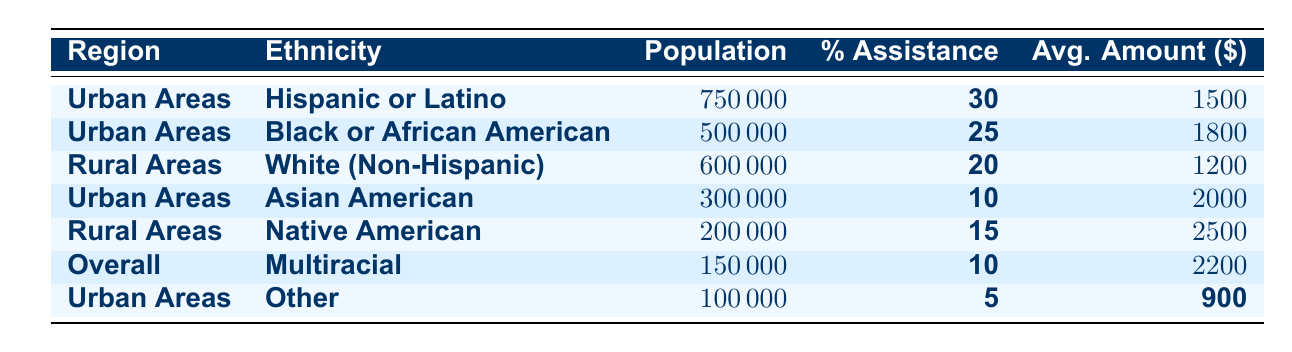What is the population size of Hispanic or Latino individuals receiving assistance in Urban Areas? The table shows that the population size for Hispanic or Latino individuals in Urban Areas is listed directly under that row. It is 750,000.
Answer: 750,000 What percentage of the population in Rural Areas is receiving assistance as Native American? Looking at the row for Native American in Rural Areas, the percentage of assistance is stated as 15 percent.
Answer: 15% Which ethnicity has the highest average assistance amount? By comparing the average amounts across all ethnicities, Native American has the highest at 2,500.
Answer: Native American What is the total population size of all diverse groups in Urban Areas? To find the total, we add the population sizes for all groups in Urban Areas: 750,000 (Hispanic or Latino) + 500,000 (Black or African American) + 300,000 (Asian American) + 100,000 (Other) = 1,650,000.
Answer: 1,650,000 Is the average assistance amount for Black or African American higher than that for Hispanic or Latino? The average assistance amount for Black or African American is 1,800, while for Hispanic or Latino, it is 1,500. Since 1,800 is greater than 1,500, the statement is true.
Answer: Yes What is the average assistance amount for all groups receiving assistance in Urban Areas? We need to calculate it by adding their average amounts and dividing by the number of groups: (1,500 + 1,800 + 2,000 + 900) / 4 = 1,550.
Answer: 1,550 Which region has more groups receiving assistance listed in the table? Upon checking the table, Urban Areas has four groups listed while Rural Areas has two groups. Therefore, Urban Areas has more groups.
Answer: Urban Areas What is the combined percentage of assistance for all groups in Urban Areas? The percentages for Urban Areas are: 30% (Hispanic or Latino) + 25% (Black or African American) + 10% (Asian American) + 5% (Other). Adding these gives 70%.
Answer: 70% Is the population size of the White (Non-Hispanic) group larger than that of the Asian American group? Yes, the population size for White (Non-Hispanic) is 600,000, which is greater than the 300,000 for the Asian American group.
Answer: Yes What is the difference in average assistance amounts between Native American and Other ethnicities? The average assistance amount for Native American is 2,500 and for Other it is 900. The difference is 2,500 - 900 = 1,600.
Answer: 1,600 What is the average population size across all ethnicities listed in the table? To find the average, we total all population sizes: 750,000 + 500,000 + 600,000 + 300,000 + 200,000 + 150,000 + 100,000 = 2,600,000. Dividing by the number of groups (7) gives 371,429 (rounded).
Answer: 371,429 